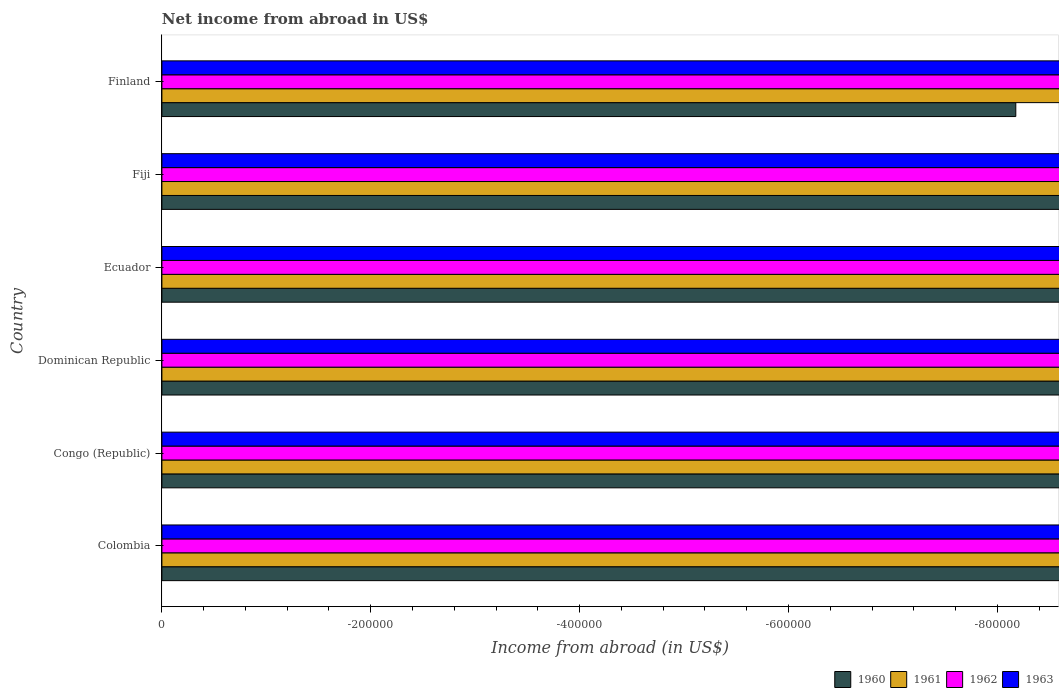Are the number of bars on each tick of the Y-axis equal?
Your answer should be very brief. Yes. What is the label of the 5th group of bars from the top?
Your response must be concise. Congo (Republic). In how many cases, is the number of bars for a given country not equal to the number of legend labels?
Offer a terse response. 6. What is the net income from abroad in 1963 in Ecuador?
Keep it short and to the point. 0. Across all countries, what is the minimum net income from abroad in 1961?
Make the answer very short. 0. What is the average net income from abroad in 1962 per country?
Keep it short and to the point. 0. In how many countries, is the net income from abroad in 1962 greater than the average net income from abroad in 1962 taken over all countries?
Ensure brevity in your answer.  0. Is it the case that in every country, the sum of the net income from abroad in 1961 and net income from abroad in 1962 is greater than the net income from abroad in 1963?
Your answer should be compact. No. How many bars are there?
Your answer should be very brief. 0. Are all the bars in the graph horizontal?
Your answer should be very brief. Yes. How many countries are there in the graph?
Your response must be concise. 6. Does the graph contain grids?
Provide a short and direct response. No. What is the title of the graph?
Ensure brevity in your answer.  Net income from abroad in US$. Does "2003" appear as one of the legend labels in the graph?
Provide a succinct answer. No. What is the label or title of the X-axis?
Offer a terse response. Income from abroad (in US$). What is the label or title of the Y-axis?
Provide a succinct answer. Country. What is the Income from abroad (in US$) of 1960 in Colombia?
Your answer should be compact. 0. What is the Income from abroad (in US$) in 1961 in Colombia?
Provide a short and direct response. 0. What is the Income from abroad (in US$) of 1963 in Colombia?
Ensure brevity in your answer.  0. What is the Income from abroad (in US$) of 1961 in Congo (Republic)?
Your answer should be very brief. 0. What is the Income from abroad (in US$) in 1963 in Congo (Republic)?
Provide a short and direct response. 0. What is the Income from abroad (in US$) of 1960 in Dominican Republic?
Make the answer very short. 0. What is the Income from abroad (in US$) of 1960 in Ecuador?
Offer a terse response. 0. What is the Income from abroad (in US$) of 1961 in Ecuador?
Offer a very short reply. 0. What is the Income from abroad (in US$) of 1962 in Ecuador?
Your answer should be compact. 0. What is the Income from abroad (in US$) in 1963 in Ecuador?
Give a very brief answer. 0. What is the Income from abroad (in US$) of 1960 in Fiji?
Your response must be concise. 0. What is the Income from abroad (in US$) of 1961 in Fiji?
Your answer should be very brief. 0. What is the Income from abroad (in US$) in 1961 in Finland?
Ensure brevity in your answer.  0. What is the total Income from abroad (in US$) of 1960 in the graph?
Provide a short and direct response. 0. What is the total Income from abroad (in US$) in 1961 in the graph?
Keep it short and to the point. 0. What is the total Income from abroad (in US$) in 1962 in the graph?
Offer a very short reply. 0. What is the average Income from abroad (in US$) in 1960 per country?
Offer a very short reply. 0. 